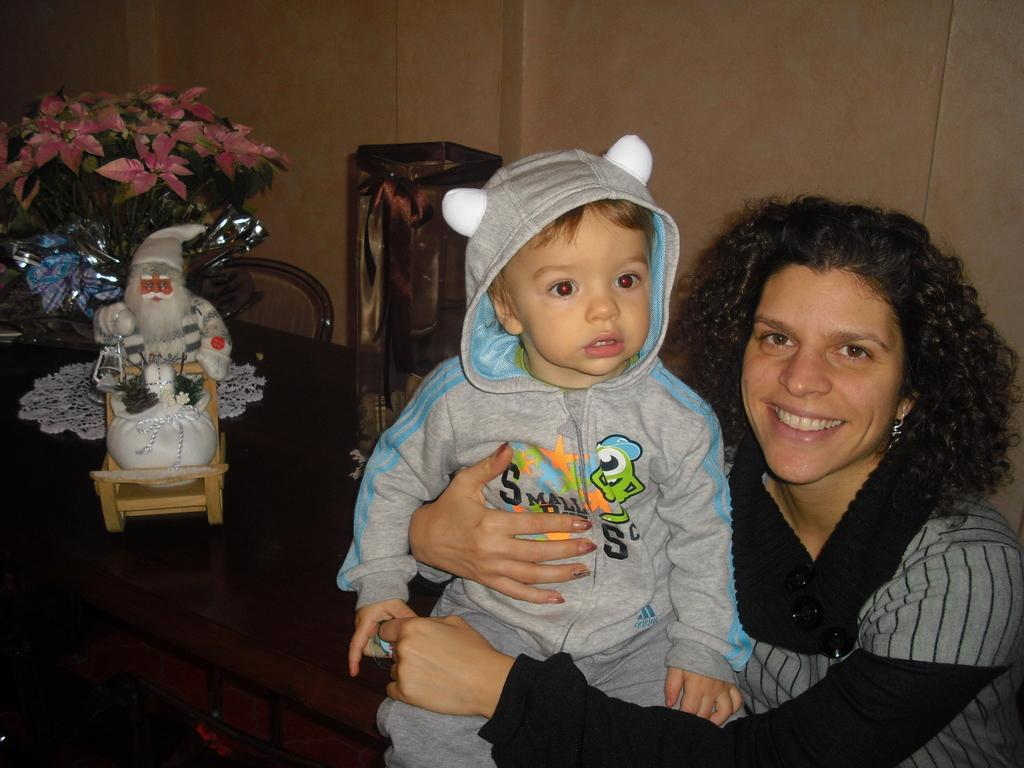What is the main subject in the center of the image? There is a baby in the center of the image. Who else is present in the image? There is a lady in the image. What can be seen in the background of the image? There is a wall in the background of the image. What is on the table in the image? There is a table with objects on it in the image. Can you see any worms crawling on the baby in the image? No, there are no worms present in the image. 